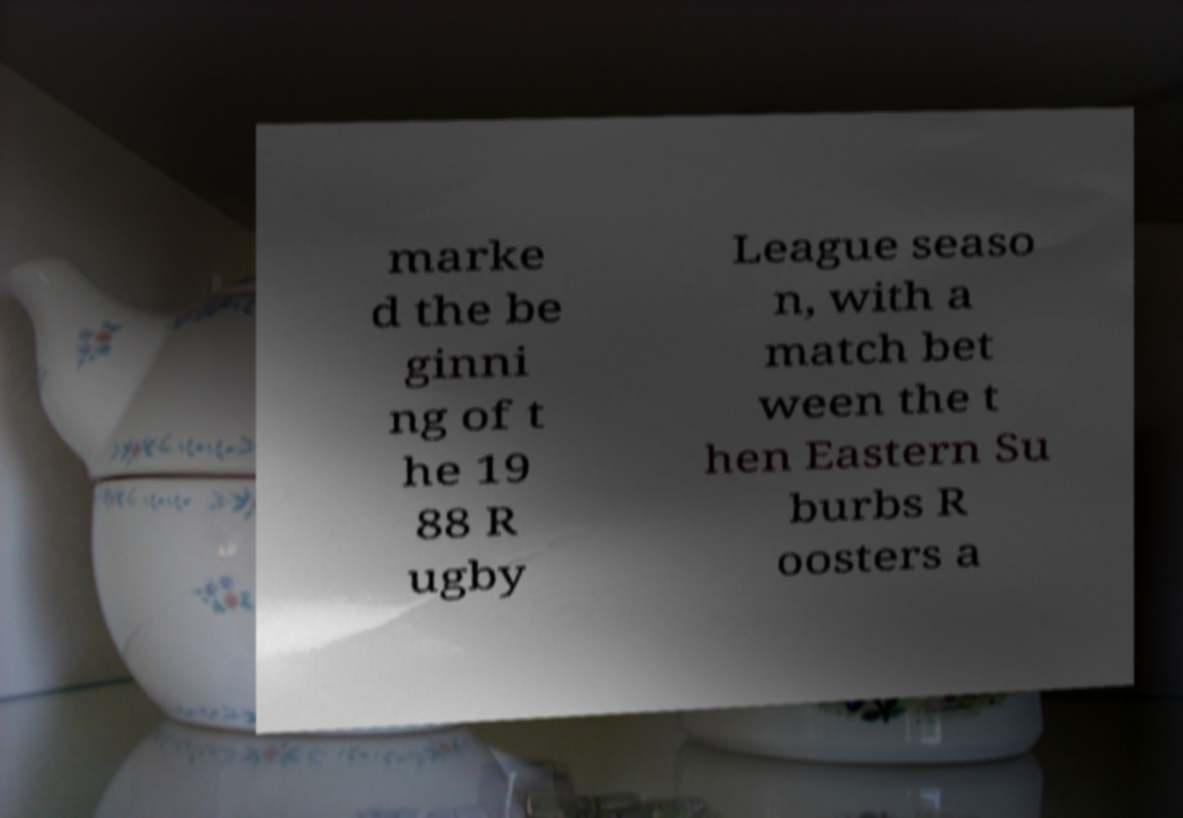Can you accurately transcribe the text from the provided image for me? marke d the be ginni ng of t he 19 88 R ugby League seaso n, with a match bet ween the t hen Eastern Su burbs R oosters a 